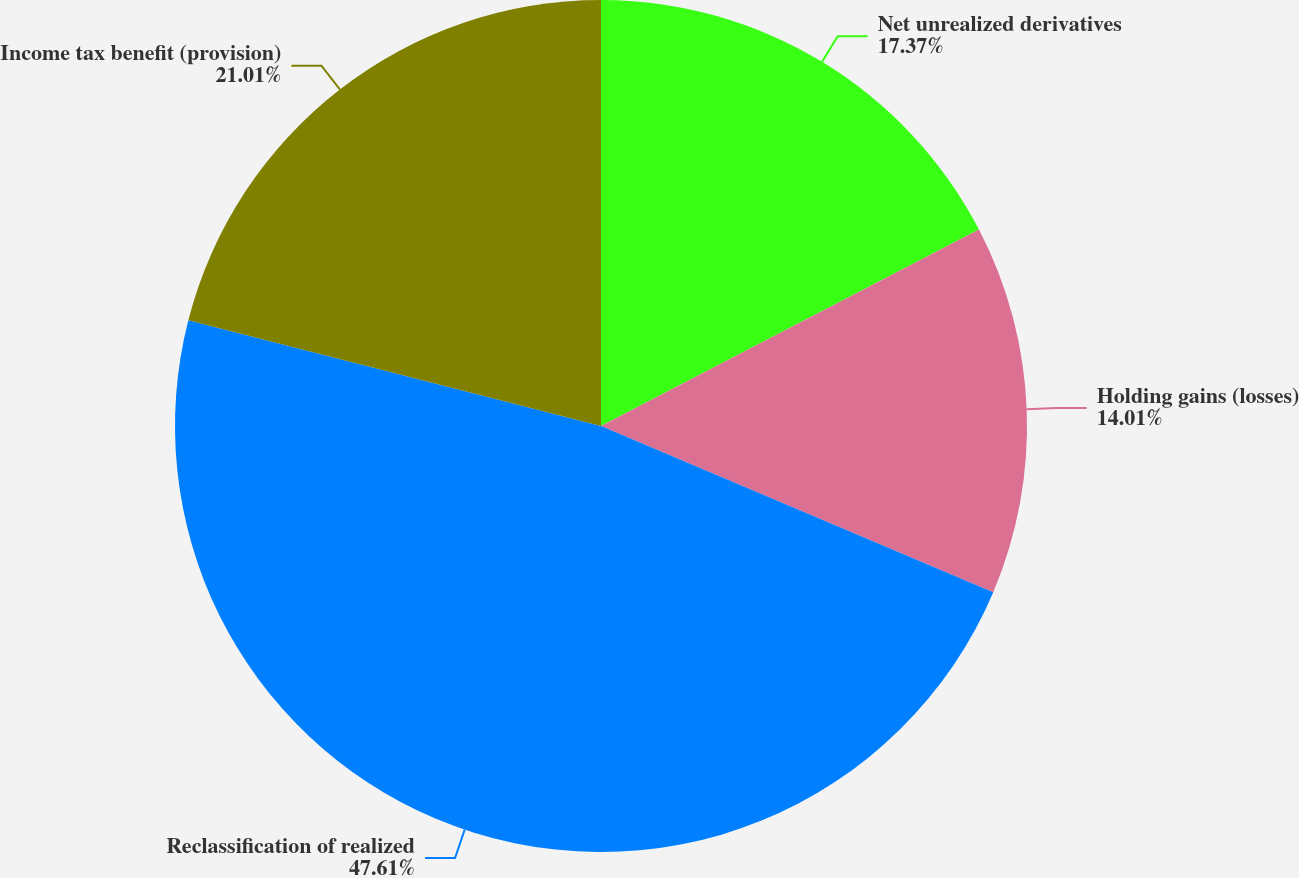<chart> <loc_0><loc_0><loc_500><loc_500><pie_chart><fcel>Net unrealized derivatives<fcel>Holding gains (losses)<fcel>Reclassification of realized<fcel>Income tax benefit (provision)<nl><fcel>17.37%<fcel>14.01%<fcel>47.62%<fcel>21.01%<nl></chart> 